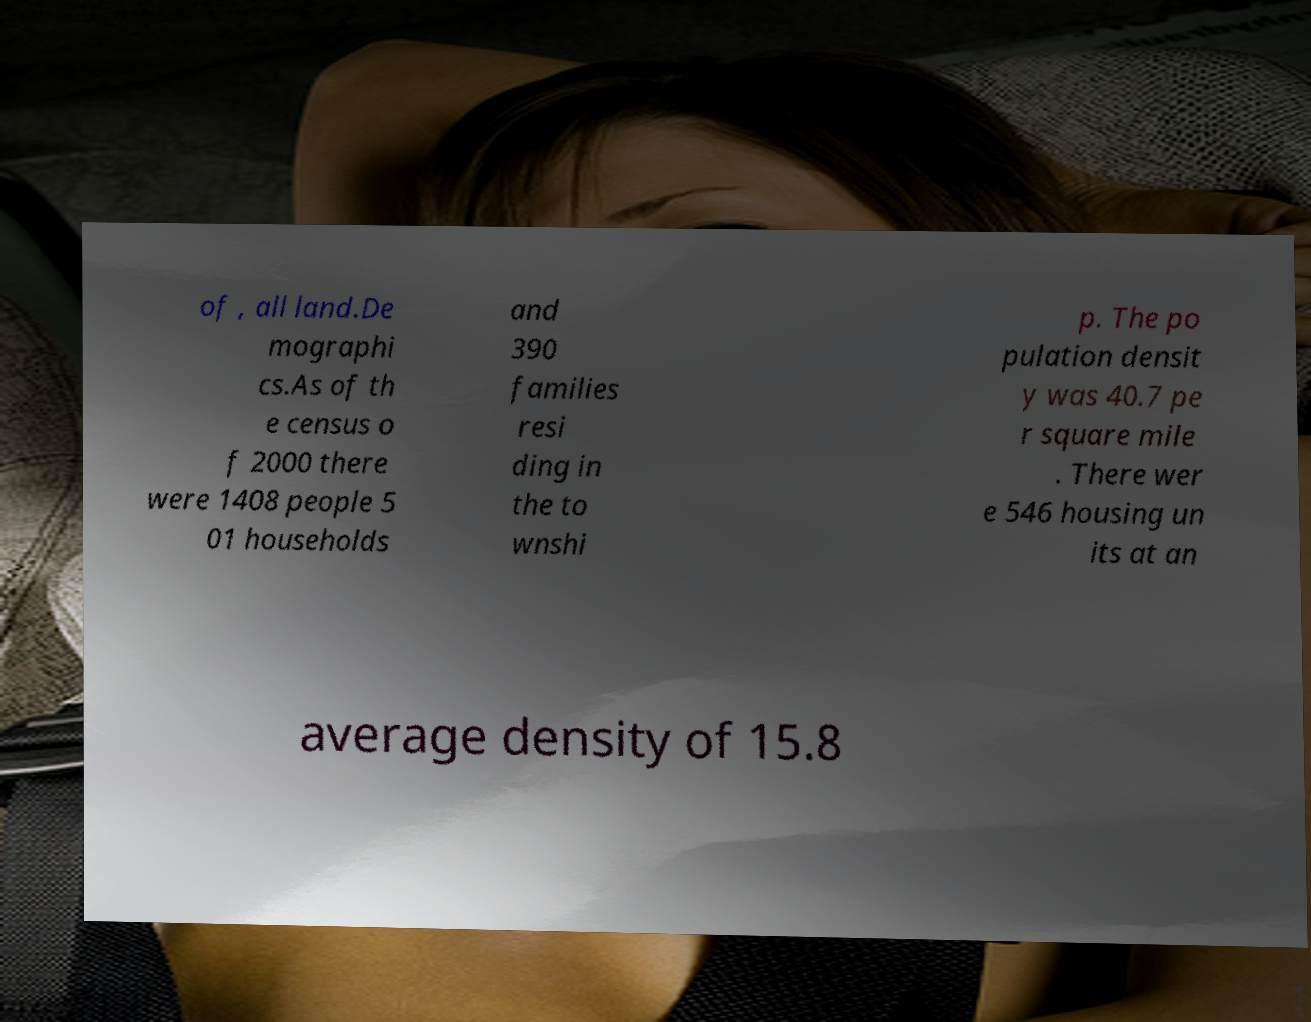Could you extract and type out the text from this image? of , all land.De mographi cs.As of th e census o f 2000 there were 1408 people 5 01 households and 390 families resi ding in the to wnshi p. The po pulation densit y was 40.7 pe r square mile . There wer e 546 housing un its at an average density of 15.8 